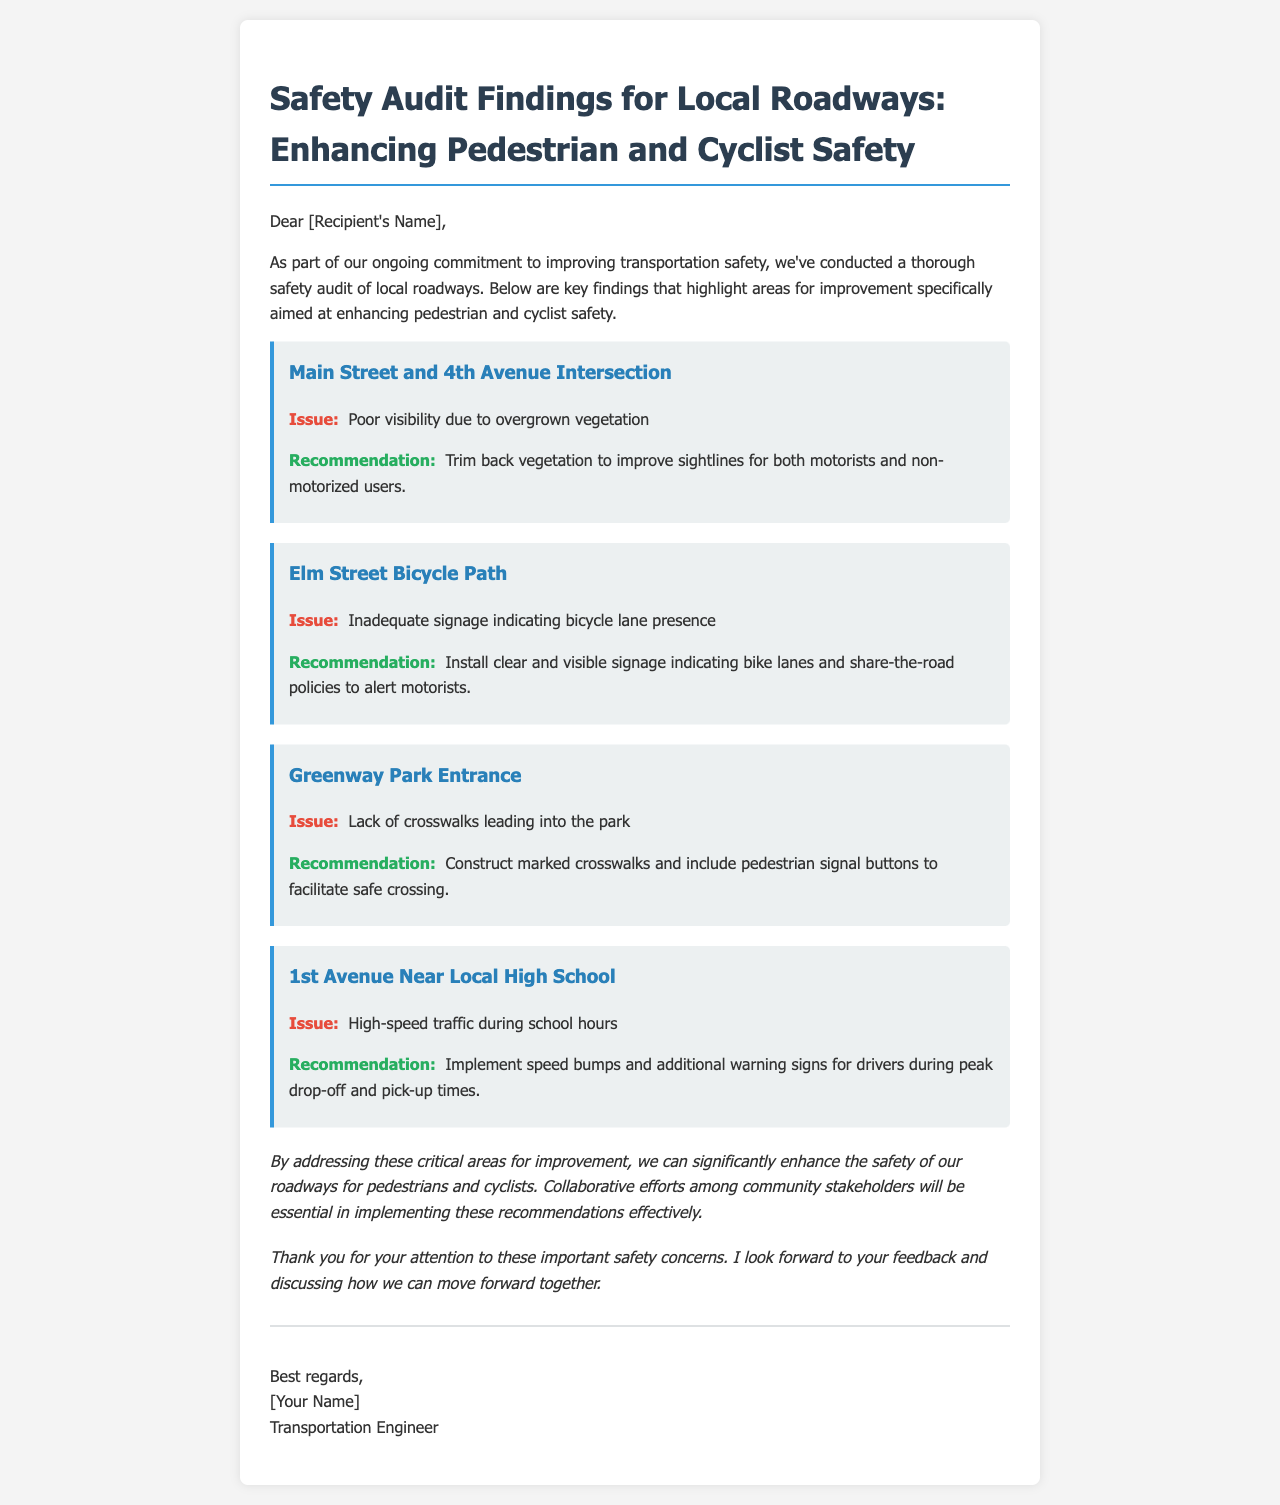What is the main purpose of the email? The purpose is to present findings from a safety audit related to local roadways to enhance pedestrian and cyclist safety.
Answer: Safety audit findings for local roadways What issue is identified at Main Street and 4th Avenue? The document specifies poor visibility due to overgrown vegetation as an issue at this intersection.
Answer: Poor visibility due to overgrown vegetation What recommendation is made for the Elm Street Bicycle Path? The recommendation involves installing clear and visible signage indicating bike lanes and share-the-road policies.
Answer: Install clear and visible signage How many findings are mentioned in the email? The document lists a total of four key findings related to roadway safety.
Answer: Four What time period is highlighted for high-speed traffic issues near the local high school? The email discusses high-speed traffic specifically during school hours as the problematic time.
Answer: School hours What is suggested to improve safety at the Greenway Park Entrance? The document recommends constructing marked crosswalks and including pedestrian signal buttons for safety.
Answer: Construct marked crosswalks Who is the author of the email? The email includes a signature that indicates the author is a Transportation Engineer.
Answer: Transportation Engineer What is the overall conclusion drawn in the email? The conclusion emphasizes that addressing critical areas for improvement can enhance safety for pedestrians and cyclists.
Answer: Enhance safety of our roadways for pedestrians and cyclists 